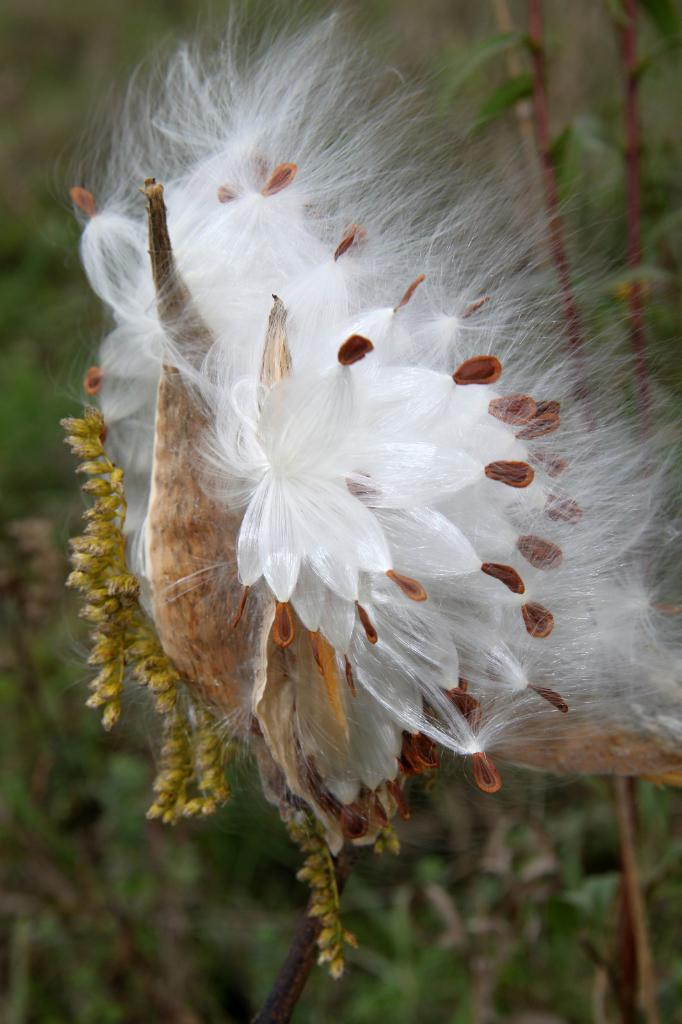What is the main subject of the image? There is a flower in the image. Can you describe the color of the flower? The flower is white and brown in color. What can be seen in the background of the image? There are plants in the background of the image. What is the color of the plants in the background? The plants are green in color. What type of knowledge is being sold at the market in the image? There is no market present in the image, and therefore no knowledge is being sold. Can you hear the sound of thunder in the image? There is no mention of thunder or any sound in the image, so it cannot be heard. 